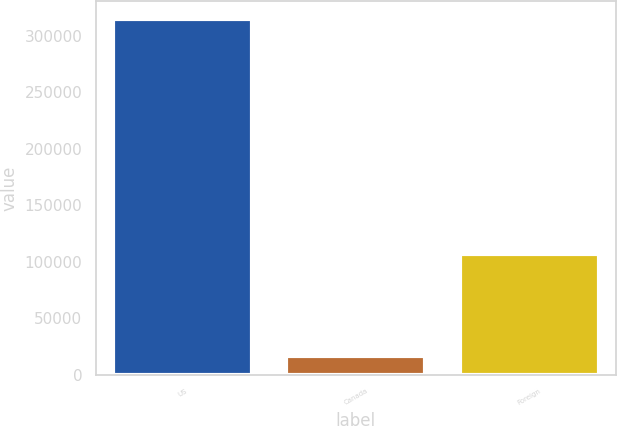Convert chart. <chart><loc_0><loc_0><loc_500><loc_500><bar_chart><fcel>US<fcel>Canada<fcel>Foreign<nl><fcel>315122<fcel>16128<fcel>106383<nl></chart> 